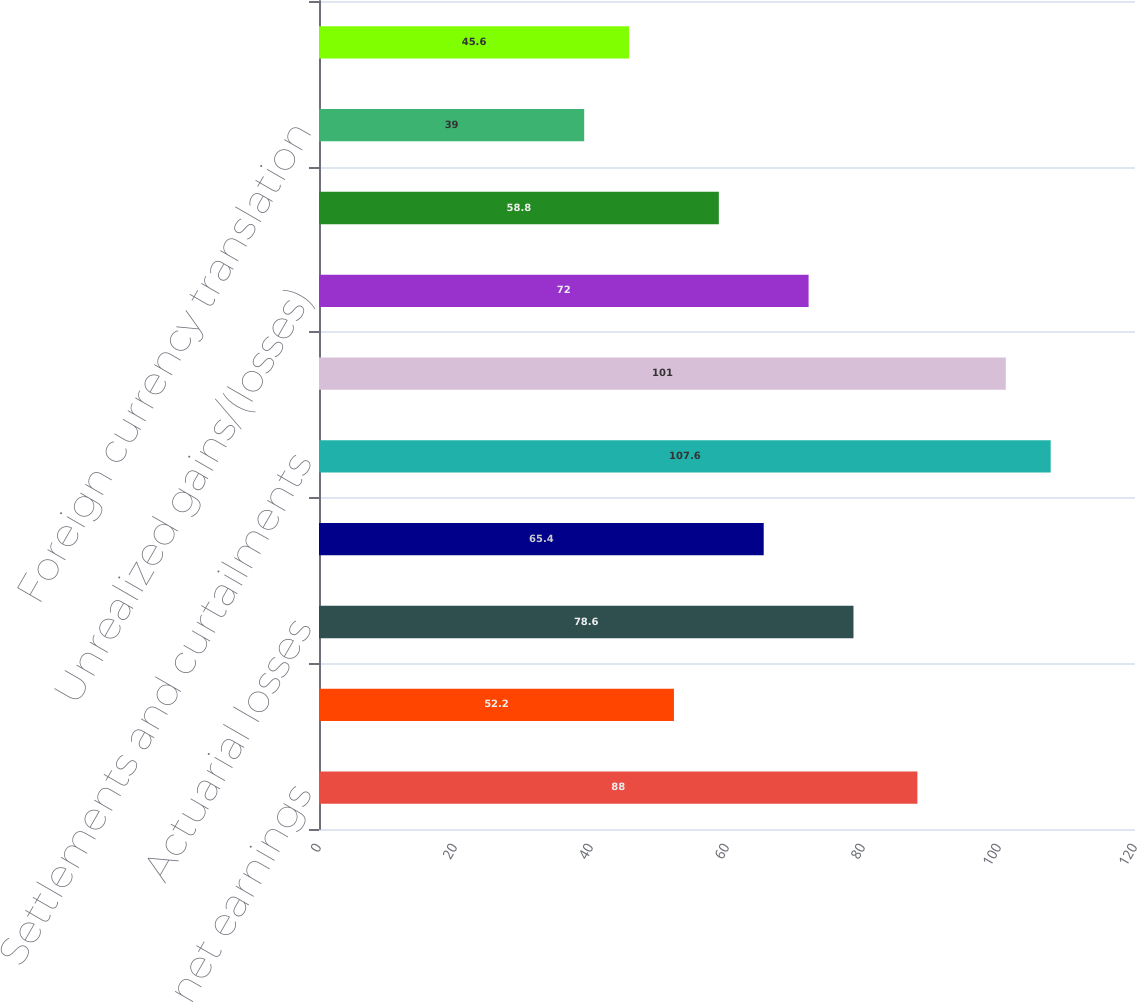Convert chart to OTSL. <chart><loc_0><loc_0><loc_500><loc_500><bar_chart><fcel>Reclassified to net earnings<fcel>Derivatives qualifying as cash<fcel>Actuarial losses<fcel>Amortization (b)<fcel>Settlements and curtailments<fcel>Pension and other<fcel>Unrealized gains/(losses)<fcel>Available-for-sale securities<fcel>Foreign currency translation<fcel>Total Other Comprehensive<nl><fcel>88<fcel>52.2<fcel>78.6<fcel>65.4<fcel>107.6<fcel>101<fcel>72<fcel>58.8<fcel>39<fcel>45.6<nl></chart> 